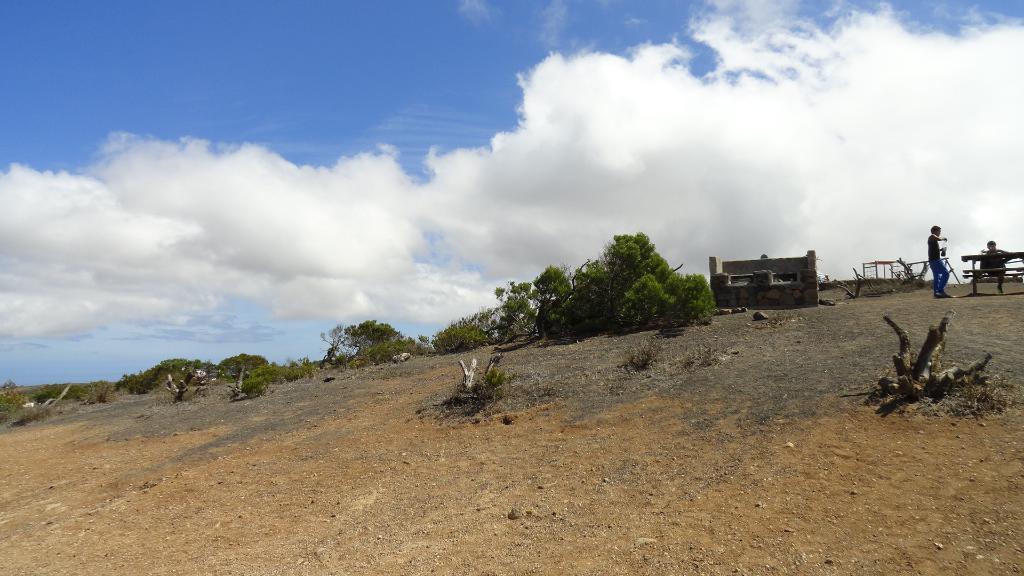How would you summarize this image in a sentence or two? In this picture we can see wooden objects, grass, wall, table and bench. There are people and we can see trees. In the background of the image we can see sky with clouds. 